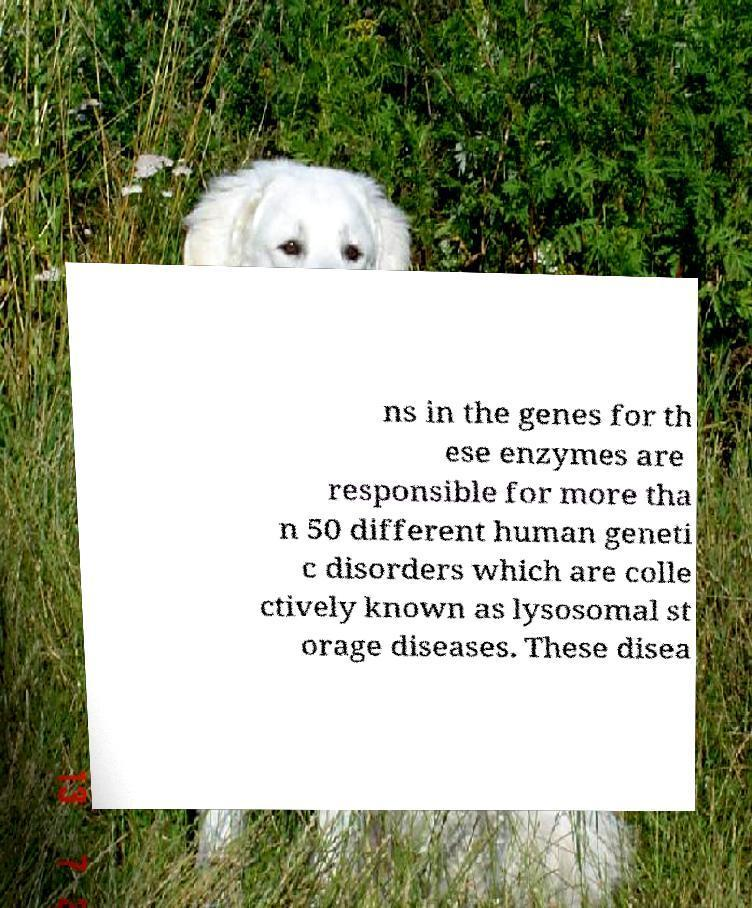Can you accurately transcribe the text from the provided image for me? ns in the genes for th ese enzymes are responsible for more tha n 50 different human geneti c disorders which are colle ctively known as lysosomal st orage diseases. These disea 